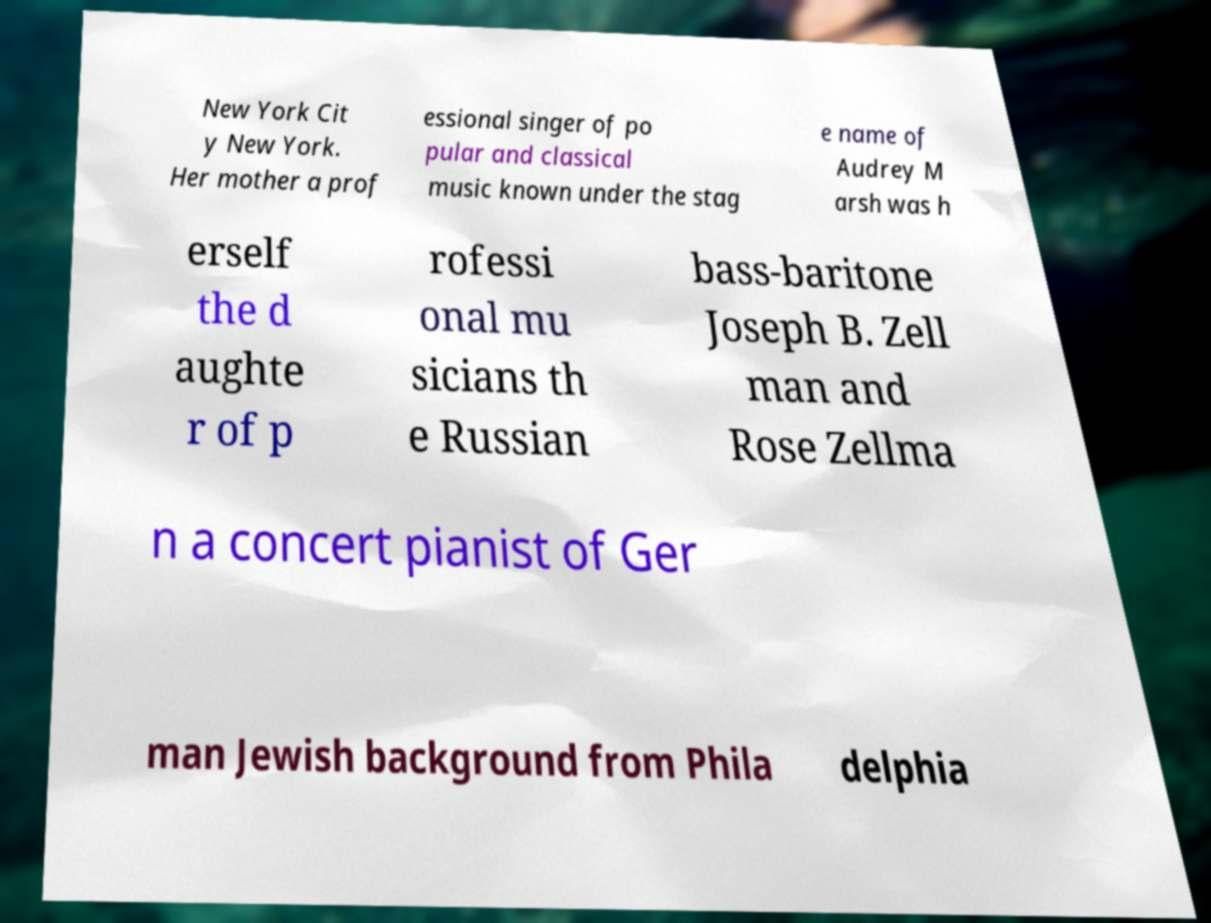For documentation purposes, I need the text within this image transcribed. Could you provide that? New York Cit y New York. Her mother a prof essional singer of po pular and classical music known under the stag e name of Audrey M arsh was h erself the d aughte r of p rofessi onal mu sicians th e Russian bass-baritone Joseph B. Zell man and Rose Zellma n a concert pianist of Ger man Jewish background from Phila delphia 